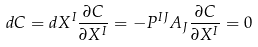Convert formula to latex. <formula><loc_0><loc_0><loc_500><loc_500>d C = d X ^ { I } \frac { \partial C } { \partial X ^ { I } } = - P ^ { I J } A _ { J } \frac { \partial C } { \partial X ^ { I } } = 0</formula> 